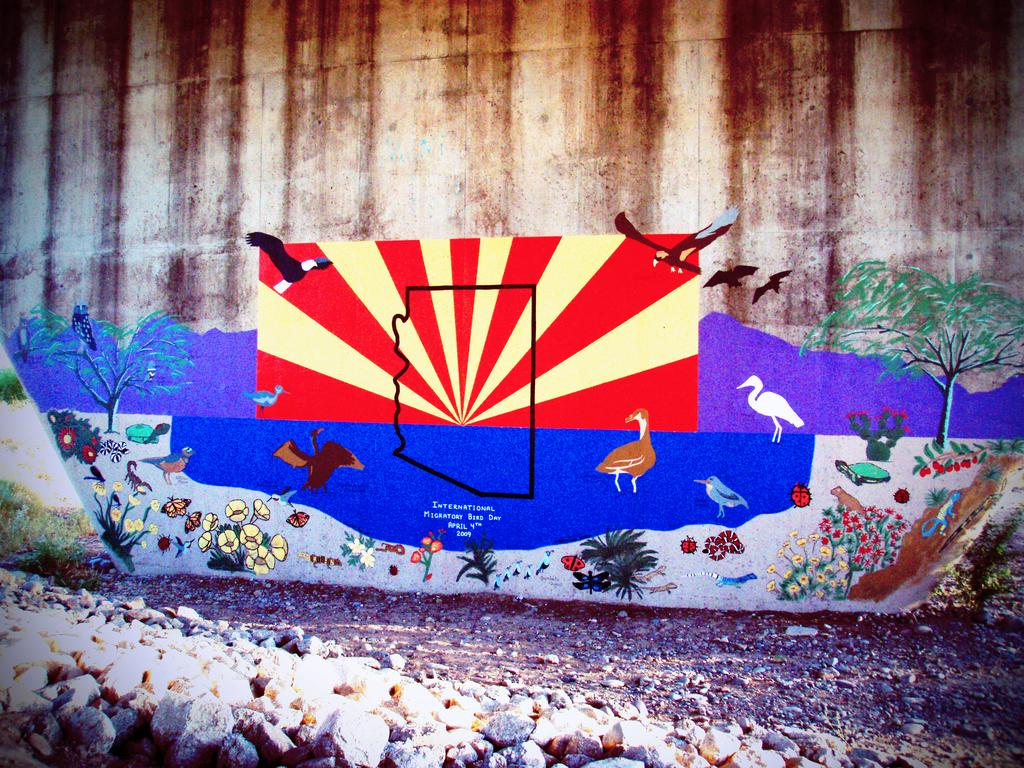What type of scene is depicted in the image? The image is an outdoor scene. What can be seen on a wall in the image? There is a painting on a wall in the image. What is included in the painting? The painting contains birds, flowers, and plants. What else can be seen in the image besides the painting? There are stones in the image. Where is the faucet located in the image? There is no faucet present in the image. What type of produce is growing in the image? There is no produce growing in the image; it features a painting with birds, flowers, and plants. 